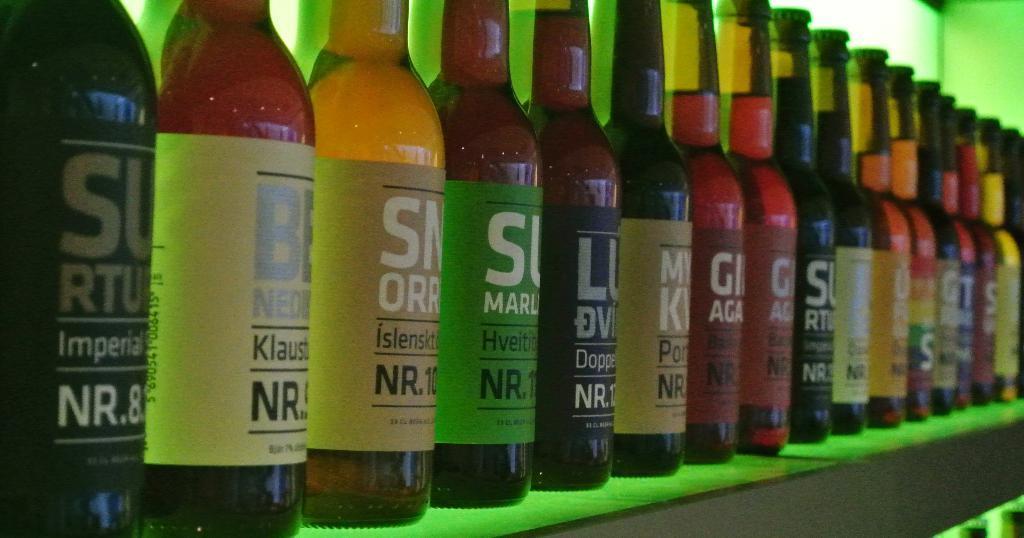In one or two sentences, can you explain what this image depicts? In the image we can see few wine bottles on the table. In the background there is a wall. 